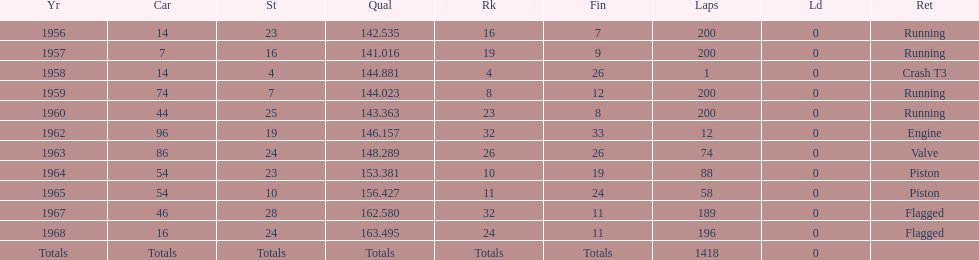What year did he have the same number car as 1964? 1965. 